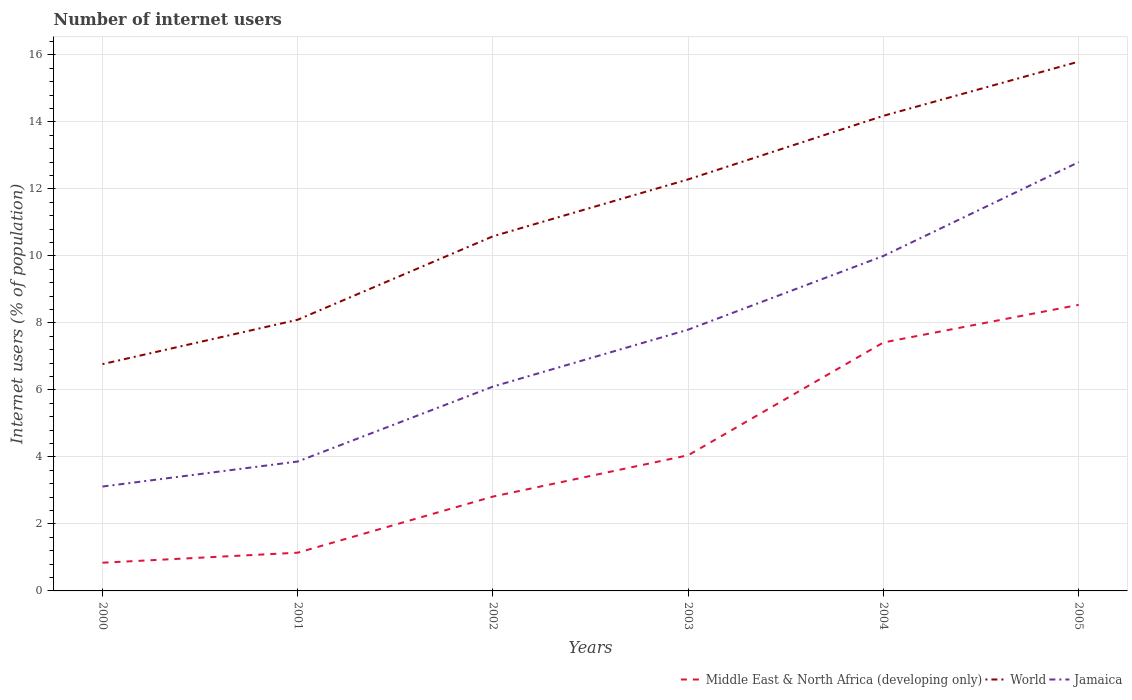How many different coloured lines are there?
Make the answer very short. 3. Does the line corresponding to Middle East & North Africa (developing only) intersect with the line corresponding to World?
Make the answer very short. No. Across all years, what is the maximum number of internet users in Middle East & North Africa (developing only)?
Ensure brevity in your answer.  0.84. In which year was the number of internet users in Jamaica maximum?
Ensure brevity in your answer.  2000. What is the total number of internet users in World in the graph?
Keep it short and to the point. -7.7. What is the difference between the highest and the second highest number of internet users in World?
Provide a succinct answer. 9.03. What is the difference between the highest and the lowest number of internet users in Middle East & North Africa (developing only)?
Give a very brief answer. 2. Is the number of internet users in World strictly greater than the number of internet users in Middle East & North Africa (developing only) over the years?
Provide a short and direct response. No. How many lines are there?
Give a very brief answer. 3. How many years are there in the graph?
Your response must be concise. 6. How many legend labels are there?
Give a very brief answer. 3. How are the legend labels stacked?
Give a very brief answer. Horizontal. What is the title of the graph?
Your answer should be very brief. Number of internet users. What is the label or title of the Y-axis?
Offer a very short reply. Internet users (% of population). What is the Internet users (% of population) of Middle East & North Africa (developing only) in 2000?
Offer a very short reply. 0.84. What is the Internet users (% of population) of World in 2000?
Make the answer very short. 6.77. What is the Internet users (% of population) in Jamaica in 2000?
Ensure brevity in your answer.  3.12. What is the Internet users (% of population) of Middle East & North Africa (developing only) in 2001?
Provide a succinct answer. 1.14. What is the Internet users (% of population) in World in 2001?
Ensure brevity in your answer.  8.1. What is the Internet users (% of population) in Jamaica in 2001?
Your response must be concise. 3.86. What is the Internet users (% of population) in Middle East & North Africa (developing only) in 2002?
Keep it short and to the point. 2.82. What is the Internet users (% of population) of World in 2002?
Provide a succinct answer. 10.59. What is the Internet users (% of population) of Jamaica in 2002?
Provide a succinct answer. 6.1. What is the Internet users (% of population) of Middle East & North Africa (developing only) in 2003?
Offer a very short reply. 4.05. What is the Internet users (% of population) of World in 2003?
Provide a short and direct response. 12.29. What is the Internet users (% of population) in Middle East & North Africa (developing only) in 2004?
Your response must be concise. 7.42. What is the Internet users (% of population) in World in 2004?
Your answer should be very brief. 14.18. What is the Internet users (% of population) in Jamaica in 2004?
Make the answer very short. 10. What is the Internet users (% of population) of Middle East & North Africa (developing only) in 2005?
Offer a very short reply. 8.54. What is the Internet users (% of population) in World in 2005?
Make the answer very short. 15.8. Across all years, what is the maximum Internet users (% of population) in Middle East & North Africa (developing only)?
Provide a short and direct response. 8.54. Across all years, what is the maximum Internet users (% of population) in World?
Provide a succinct answer. 15.8. Across all years, what is the maximum Internet users (% of population) in Jamaica?
Make the answer very short. 12.8. Across all years, what is the minimum Internet users (% of population) of Middle East & North Africa (developing only)?
Ensure brevity in your answer.  0.84. Across all years, what is the minimum Internet users (% of population) of World?
Provide a short and direct response. 6.77. Across all years, what is the minimum Internet users (% of population) of Jamaica?
Offer a very short reply. 3.12. What is the total Internet users (% of population) in Middle East & North Africa (developing only) in the graph?
Your response must be concise. 24.81. What is the total Internet users (% of population) of World in the graph?
Your answer should be compact. 67.72. What is the total Internet users (% of population) in Jamaica in the graph?
Make the answer very short. 43.68. What is the difference between the Internet users (% of population) in Middle East & North Africa (developing only) in 2000 and that in 2001?
Offer a terse response. -0.3. What is the difference between the Internet users (% of population) of World in 2000 and that in 2001?
Keep it short and to the point. -1.33. What is the difference between the Internet users (% of population) in Jamaica in 2000 and that in 2001?
Offer a terse response. -0.75. What is the difference between the Internet users (% of population) of Middle East & North Africa (developing only) in 2000 and that in 2002?
Offer a terse response. -1.97. What is the difference between the Internet users (% of population) of World in 2000 and that in 2002?
Offer a very short reply. -3.82. What is the difference between the Internet users (% of population) of Jamaica in 2000 and that in 2002?
Offer a very short reply. -2.98. What is the difference between the Internet users (% of population) of Middle East & North Africa (developing only) in 2000 and that in 2003?
Offer a very short reply. -3.21. What is the difference between the Internet users (% of population) in World in 2000 and that in 2003?
Offer a terse response. -5.51. What is the difference between the Internet users (% of population) of Jamaica in 2000 and that in 2003?
Keep it short and to the point. -4.68. What is the difference between the Internet users (% of population) of Middle East & North Africa (developing only) in 2000 and that in 2004?
Your answer should be compact. -6.57. What is the difference between the Internet users (% of population) in World in 2000 and that in 2004?
Give a very brief answer. -7.41. What is the difference between the Internet users (% of population) of Jamaica in 2000 and that in 2004?
Ensure brevity in your answer.  -6.88. What is the difference between the Internet users (% of population) of Middle East & North Africa (developing only) in 2000 and that in 2005?
Provide a succinct answer. -7.7. What is the difference between the Internet users (% of population) of World in 2000 and that in 2005?
Ensure brevity in your answer.  -9.03. What is the difference between the Internet users (% of population) in Jamaica in 2000 and that in 2005?
Your answer should be very brief. -9.68. What is the difference between the Internet users (% of population) in Middle East & North Africa (developing only) in 2001 and that in 2002?
Provide a short and direct response. -1.68. What is the difference between the Internet users (% of population) of World in 2001 and that in 2002?
Ensure brevity in your answer.  -2.49. What is the difference between the Internet users (% of population) in Jamaica in 2001 and that in 2002?
Keep it short and to the point. -2.24. What is the difference between the Internet users (% of population) in Middle East & North Africa (developing only) in 2001 and that in 2003?
Keep it short and to the point. -2.91. What is the difference between the Internet users (% of population) of World in 2001 and that in 2003?
Provide a short and direct response. -4.19. What is the difference between the Internet users (% of population) of Jamaica in 2001 and that in 2003?
Offer a very short reply. -3.94. What is the difference between the Internet users (% of population) in Middle East & North Africa (developing only) in 2001 and that in 2004?
Keep it short and to the point. -6.28. What is the difference between the Internet users (% of population) of World in 2001 and that in 2004?
Ensure brevity in your answer.  -6.09. What is the difference between the Internet users (% of population) of Jamaica in 2001 and that in 2004?
Your answer should be compact. -6.14. What is the difference between the Internet users (% of population) of Middle East & North Africa (developing only) in 2001 and that in 2005?
Offer a terse response. -7.4. What is the difference between the Internet users (% of population) of World in 2001 and that in 2005?
Your answer should be compact. -7.7. What is the difference between the Internet users (% of population) in Jamaica in 2001 and that in 2005?
Keep it short and to the point. -8.94. What is the difference between the Internet users (% of population) of Middle East & North Africa (developing only) in 2002 and that in 2003?
Give a very brief answer. -1.23. What is the difference between the Internet users (% of population) of World in 2002 and that in 2003?
Provide a succinct answer. -1.7. What is the difference between the Internet users (% of population) of Middle East & North Africa (developing only) in 2002 and that in 2004?
Ensure brevity in your answer.  -4.6. What is the difference between the Internet users (% of population) of World in 2002 and that in 2004?
Ensure brevity in your answer.  -3.6. What is the difference between the Internet users (% of population) in Jamaica in 2002 and that in 2004?
Your answer should be very brief. -3.9. What is the difference between the Internet users (% of population) of Middle East & North Africa (developing only) in 2002 and that in 2005?
Make the answer very short. -5.72. What is the difference between the Internet users (% of population) of World in 2002 and that in 2005?
Offer a terse response. -5.21. What is the difference between the Internet users (% of population) in Middle East & North Africa (developing only) in 2003 and that in 2004?
Offer a very short reply. -3.37. What is the difference between the Internet users (% of population) of World in 2003 and that in 2004?
Offer a terse response. -1.9. What is the difference between the Internet users (% of population) of Middle East & North Africa (developing only) in 2003 and that in 2005?
Make the answer very short. -4.49. What is the difference between the Internet users (% of population) in World in 2003 and that in 2005?
Ensure brevity in your answer.  -3.51. What is the difference between the Internet users (% of population) of Jamaica in 2003 and that in 2005?
Provide a succinct answer. -5. What is the difference between the Internet users (% of population) of Middle East & North Africa (developing only) in 2004 and that in 2005?
Offer a terse response. -1.12. What is the difference between the Internet users (% of population) of World in 2004 and that in 2005?
Offer a very short reply. -1.62. What is the difference between the Internet users (% of population) in Jamaica in 2004 and that in 2005?
Your answer should be very brief. -2.8. What is the difference between the Internet users (% of population) of Middle East & North Africa (developing only) in 2000 and the Internet users (% of population) of World in 2001?
Your response must be concise. -7.25. What is the difference between the Internet users (% of population) in Middle East & North Africa (developing only) in 2000 and the Internet users (% of population) in Jamaica in 2001?
Ensure brevity in your answer.  -3.02. What is the difference between the Internet users (% of population) in World in 2000 and the Internet users (% of population) in Jamaica in 2001?
Make the answer very short. 2.91. What is the difference between the Internet users (% of population) of Middle East & North Africa (developing only) in 2000 and the Internet users (% of population) of World in 2002?
Provide a short and direct response. -9.74. What is the difference between the Internet users (% of population) in Middle East & North Africa (developing only) in 2000 and the Internet users (% of population) in Jamaica in 2002?
Provide a short and direct response. -5.26. What is the difference between the Internet users (% of population) in World in 2000 and the Internet users (% of population) in Jamaica in 2002?
Your answer should be very brief. 0.67. What is the difference between the Internet users (% of population) of Middle East & North Africa (developing only) in 2000 and the Internet users (% of population) of World in 2003?
Keep it short and to the point. -11.44. What is the difference between the Internet users (% of population) in Middle East & North Africa (developing only) in 2000 and the Internet users (% of population) in Jamaica in 2003?
Give a very brief answer. -6.96. What is the difference between the Internet users (% of population) in World in 2000 and the Internet users (% of population) in Jamaica in 2003?
Provide a succinct answer. -1.03. What is the difference between the Internet users (% of population) in Middle East & North Africa (developing only) in 2000 and the Internet users (% of population) in World in 2004?
Your answer should be compact. -13.34. What is the difference between the Internet users (% of population) in Middle East & North Africa (developing only) in 2000 and the Internet users (% of population) in Jamaica in 2004?
Provide a succinct answer. -9.16. What is the difference between the Internet users (% of population) in World in 2000 and the Internet users (% of population) in Jamaica in 2004?
Your response must be concise. -3.23. What is the difference between the Internet users (% of population) of Middle East & North Africa (developing only) in 2000 and the Internet users (% of population) of World in 2005?
Give a very brief answer. -14.96. What is the difference between the Internet users (% of population) of Middle East & North Africa (developing only) in 2000 and the Internet users (% of population) of Jamaica in 2005?
Make the answer very short. -11.96. What is the difference between the Internet users (% of population) of World in 2000 and the Internet users (% of population) of Jamaica in 2005?
Your answer should be compact. -6.03. What is the difference between the Internet users (% of population) of Middle East & North Africa (developing only) in 2001 and the Internet users (% of population) of World in 2002?
Ensure brevity in your answer.  -9.45. What is the difference between the Internet users (% of population) in Middle East & North Africa (developing only) in 2001 and the Internet users (% of population) in Jamaica in 2002?
Your answer should be very brief. -4.96. What is the difference between the Internet users (% of population) of World in 2001 and the Internet users (% of population) of Jamaica in 2002?
Offer a very short reply. 2. What is the difference between the Internet users (% of population) in Middle East & North Africa (developing only) in 2001 and the Internet users (% of population) in World in 2003?
Provide a succinct answer. -11.14. What is the difference between the Internet users (% of population) in Middle East & North Africa (developing only) in 2001 and the Internet users (% of population) in Jamaica in 2003?
Ensure brevity in your answer.  -6.66. What is the difference between the Internet users (% of population) of World in 2001 and the Internet users (% of population) of Jamaica in 2003?
Give a very brief answer. 0.3. What is the difference between the Internet users (% of population) of Middle East & North Africa (developing only) in 2001 and the Internet users (% of population) of World in 2004?
Your response must be concise. -13.04. What is the difference between the Internet users (% of population) in Middle East & North Africa (developing only) in 2001 and the Internet users (% of population) in Jamaica in 2004?
Give a very brief answer. -8.86. What is the difference between the Internet users (% of population) of World in 2001 and the Internet users (% of population) of Jamaica in 2004?
Offer a very short reply. -1.9. What is the difference between the Internet users (% of population) of Middle East & North Africa (developing only) in 2001 and the Internet users (% of population) of World in 2005?
Your answer should be very brief. -14.66. What is the difference between the Internet users (% of population) of Middle East & North Africa (developing only) in 2001 and the Internet users (% of population) of Jamaica in 2005?
Give a very brief answer. -11.66. What is the difference between the Internet users (% of population) in World in 2001 and the Internet users (% of population) in Jamaica in 2005?
Offer a very short reply. -4.7. What is the difference between the Internet users (% of population) in Middle East & North Africa (developing only) in 2002 and the Internet users (% of population) in World in 2003?
Your answer should be compact. -9.47. What is the difference between the Internet users (% of population) in Middle East & North Africa (developing only) in 2002 and the Internet users (% of population) in Jamaica in 2003?
Offer a very short reply. -4.98. What is the difference between the Internet users (% of population) of World in 2002 and the Internet users (% of population) of Jamaica in 2003?
Provide a short and direct response. 2.79. What is the difference between the Internet users (% of population) in Middle East & North Africa (developing only) in 2002 and the Internet users (% of population) in World in 2004?
Keep it short and to the point. -11.37. What is the difference between the Internet users (% of population) of Middle East & North Africa (developing only) in 2002 and the Internet users (% of population) of Jamaica in 2004?
Offer a terse response. -7.18. What is the difference between the Internet users (% of population) in World in 2002 and the Internet users (% of population) in Jamaica in 2004?
Make the answer very short. 0.59. What is the difference between the Internet users (% of population) of Middle East & North Africa (developing only) in 2002 and the Internet users (% of population) of World in 2005?
Your answer should be compact. -12.98. What is the difference between the Internet users (% of population) in Middle East & North Africa (developing only) in 2002 and the Internet users (% of population) in Jamaica in 2005?
Offer a terse response. -9.98. What is the difference between the Internet users (% of population) in World in 2002 and the Internet users (% of population) in Jamaica in 2005?
Keep it short and to the point. -2.21. What is the difference between the Internet users (% of population) of Middle East & North Africa (developing only) in 2003 and the Internet users (% of population) of World in 2004?
Offer a terse response. -10.13. What is the difference between the Internet users (% of population) of Middle East & North Africa (developing only) in 2003 and the Internet users (% of population) of Jamaica in 2004?
Keep it short and to the point. -5.95. What is the difference between the Internet users (% of population) of World in 2003 and the Internet users (% of population) of Jamaica in 2004?
Ensure brevity in your answer.  2.29. What is the difference between the Internet users (% of population) of Middle East & North Africa (developing only) in 2003 and the Internet users (% of population) of World in 2005?
Offer a very short reply. -11.75. What is the difference between the Internet users (% of population) of Middle East & North Africa (developing only) in 2003 and the Internet users (% of population) of Jamaica in 2005?
Give a very brief answer. -8.75. What is the difference between the Internet users (% of population) in World in 2003 and the Internet users (% of population) in Jamaica in 2005?
Provide a short and direct response. -0.51. What is the difference between the Internet users (% of population) of Middle East & North Africa (developing only) in 2004 and the Internet users (% of population) of World in 2005?
Offer a very short reply. -8.38. What is the difference between the Internet users (% of population) in Middle East & North Africa (developing only) in 2004 and the Internet users (% of population) in Jamaica in 2005?
Give a very brief answer. -5.38. What is the difference between the Internet users (% of population) in World in 2004 and the Internet users (% of population) in Jamaica in 2005?
Provide a succinct answer. 1.38. What is the average Internet users (% of population) in Middle East & North Africa (developing only) per year?
Offer a very short reply. 4.13. What is the average Internet users (% of population) in World per year?
Your response must be concise. 11.29. What is the average Internet users (% of population) of Jamaica per year?
Your answer should be compact. 7.28. In the year 2000, what is the difference between the Internet users (% of population) in Middle East & North Africa (developing only) and Internet users (% of population) in World?
Make the answer very short. -5.93. In the year 2000, what is the difference between the Internet users (% of population) in Middle East & North Africa (developing only) and Internet users (% of population) in Jamaica?
Offer a terse response. -2.27. In the year 2000, what is the difference between the Internet users (% of population) of World and Internet users (% of population) of Jamaica?
Your response must be concise. 3.65. In the year 2001, what is the difference between the Internet users (% of population) in Middle East & North Africa (developing only) and Internet users (% of population) in World?
Offer a terse response. -6.95. In the year 2001, what is the difference between the Internet users (% of population) in Middle East & North Africa (developing only) and Internet users (% of population) in Jamaica?
Keep it short and to the point. -2.72. In the year 2001, what is the difference between the Internet users (% of population) of World and Internet users (% of population) of Jamaica?
Keep it short and to the point. 4.23. In the year 2002, what is the difference between the Internet users (% of population) in Middle East & North Africa (developing only) and Internet users (% of population) in World?
Your answer should be very brief. -7.77. In the year 2002, what is the difference between the Internet users (% of population) of Middle East & North Africa (developing only) and Internet users (% of population) of Jamaica?
Ensure brevity in your answer.  -3.28. In the year 2002, what is the difference between the Internet users (% of population) of World and Internet users (% of population) of Jamaica?
Provide a succinct answer. 4.49. In the year 2003, what is the difference between the Internet users (% of population) of Middle East & North Africa (developing only) and Internet users (% of population) of World?
Provide a short and direct response. -8.24. In the year 2003, what is the difference between the Internet users (% of population) in Middle East & North Africa (developing only) and Internet users (% of population) in Jamaica?
Provide a succinct answer. -3.75. In the year 2003, what is the difference between the Internet users (% of population) of World and Internet users (% of population) of Jamaica?
Provide a succinct answer. 4.49. In the year 2004, what is the difference between the Internet users (% of population) in Middle East & North Africa (developing only) and Internet users (% of population) in World?
Provide a short and direct response. -6.77. In the year 2004, what is the difference between the Internet users (% of population) of Middle East & North Africa (developing only) and Internet users (% of population) of Jamaica?
Your answer should be compact. -2.58. In the year 2004, what is the difference between the Internet users (% of population) in World and Internet users (% of population) in Jamaica?
Your answer should be compact. 4.18. In the year 2005, what is the difference between the Internet users (% of population) of Middle East & North Africa (developing only) and Internet users (% of population) of World?
Keep it short and to the point. -7.26. In the year 2005, what is the difference between the Internet users (% of population) of Middle East & North Africa (developing only) and Internet users (% of population) of Jamaica?
Ensure brevity in your answer.  -4.26. What is the ratio of the Internet users (% of population) of Middle East & North Africa (developing only) in 2000 to that in 2001?
Your answer should be very brief. 0.74. What is the ratio of the Internet users (% of population) in World in 2000 to that in 2001?
Your answer should be compact. 0.84. What is the ratio of the Internet users (% of population) in Jamaica in 2000 to that in 2001?
Your response must be concise. 0.81. What is the ratio of the Internet users (% of population) of Middle East & North Africa (developing only) in 2000 to that in 2002?
Give a very brief answer. 0.3. What is the ratio of the Internet users (% of population) of World in 2000 to that in 2002?
Your response must be concise. 0.64. What is the ratio of the Internet users (% of population) of Jamaica in 2000 to that in 2002?
Offer a terse response. 0.51. What is the ratio of the Internet users (% of population) of Middle East & North Africa (developing only) in 2000 to that in 2003?
Offer a terse response. 0.21. What is the ratio of the Internet users (% of population) of World in 2000 to that in 2003?
Your answer should be compact. 0.55. What is the ratio of the Internet users (% of population) of Jamaica in 2000 to that in 2003?
Your answer should be very brief. 0.4. What is the ratio of the Internet users (% of population) of Middle East & North Africa (developing only) in 2000 to that in 2004?
Offer a terse response. 0.11. What is the ratio of the Internet users (% of population) of World in 2000 to that in 2004?
Make the answer very short. 0.48. What is the ratio of the Internet users (% of population) of Jamaica in 2000 to that in 2004?
Offer a very short reply. 0.31. What is the ratio of the Internet users (% of population) of Middle East & North Africa (developing only) in 2000 to that in 2005?
Your answer should be very brief. 0.1. What is the ratio of the Internet users (% of population) in World in 2000 to that in 2005?
Ensure brevity in your answer.  0.43. What is the ratio of the Internet users (% of population) in Jamaica in 2000 to that in 2005?
Ensure brevity in your answer.  0.24. What is the ratio of the Internet users (% of population) in Middle East & North Africa (developing only) in 2001 to that in 2002?
Your response must be concise. 0.41. What is the ratio of the Internet users (% of population) in World in 2001 to that in 2002?
Give a very brief answer. 0.76. What is the ratio of the Internet users (% of population) of Jamaica in 2001 to that in 2002?
Your answer should be very brief. 0.63. What is the ratio of the Internet users (% of population) of Middle East & North Africa (developing only) in 2001 to that in 2003?
Your answer should be compact. 0.28. What is the ratio of the Internet users (% of population) in World in 2001 to that in 2003?
Provide a short and direct response. 0.66. What is the ratio of the Internet users (% of population) of Jamaica in 2001 to that in 2003?
Make the answer very short. 0.5. What is the ratio of the Internet users (% of population) of Middle East & North Africa (developing only) in 2001 to that in 2004?
Offer a very short reply. 0.15. What is the ratio of the Internet users (% of population) of World in 2001 to that in 2004?
Give a very brief answer. 0.57. What is the ratio of the Internet users (% of population) in Jamaica in 2001 to that in 2004?
Keep it short and to the point. 0.39. What is the ratio of the Internet users (% of population) of Middle East & North Africa (developing only) in 2001 to that in 2005?
Offer a terse response. 0.13. What is the ratio of the Internet users (% of population) in World in 2001 to that in 2005?
Keep it short and to the point. 0.51. What is the ratio of the Internet users (% of population) in Jamaica in 2001 to that in 2005?
Ensure brevity in your answer.  0.3. What is the ratio of the Internet users (% of population) of Middle East & North Africa (developing only) in 2002 to that in 2003?
Offer a terse response. 0.7. What is the ratio of the Internet users (% of population) in World in 2002 to that in 2003?
Your answer should be compact. 0.86. What is the ratio of the Internet users (% of population) of Jamaica in 2002 to that in 2003?
Offer a very short reply. 0.78. What is the ratio of the Internet users (% of population) in Middle East & North Africa (developing only) in 2002 to that in 2004?
Your answer should be very brief. 0.38. What is the ratio of the Internet users (% of population) in World in 2002 to that in 2004?
Your answer should be very brief. 0.75. What is the ratio of the Internet users (% of population) in Jamaica in 2002 to that in 2004?
Your answer should be compact. 0.61. What is the ratio of the Internet users (% of population) of Middle East & North Africa (developing only) in 2002 to that in 2005?
Make the answer very short. 0.33. What is the ratio of the Internet users (% of population) in World in 2002 to that in 2005?
Offer a very short reply. 0.67. What is the ratio of the Internet users (% of population) in Jamaica in 2002 to that in 2005?
Keep it short and to the point. 0.48. What is the ratio of the Internet users (% of population) in Middle East & North Africa (developing only) in 2003 to that in 2004?
Your answer should be compact. 0.55. What is the ratio of the Internet users (% of population) of World in 2003 to that in 2004?
Make the answer very short. 0.87. What is the ratio of the Internet users (% of population) in Jamaica in 2003 to that in 2004?
Offer a terse response. 0.78. What is the ratio of the Internet users (% of population) in Middle East & North Africa (developing only) in 2003 to that in 2005?
Offer a terse response. 0.47. What is the ratio of the Internet users (% of population) of World in 2003 to that in 2005?
Give a very brief answer. 0.78. What is the ratio of the Internet users (% of population) in Jamaica in 2003 to that in 2005?
Provide a short and direct response. 0.61. What is the ratio of the Internet users (% of population) in Middle East & North Africa (developing only) in 2004 to that in 2005?
Keep it short and to the point. 0.87. What is the ratio of the Internet users (% of population) in World in 2004 to that in 2005?
Offer a very short reply. 0.9. What is the ratio of the Internet users (% of population) in Jamaica in 2004 to that in 2005?
Your response must be concise. 0.78. What is the difference between the highest and the second highest Internet users (% of population) of Middle East & North Africa (developing only)?
Provide a succinct answer. 1.12. What is the difference between the highest and the second highest Internet users (% of population) of World?
Your response must be concise. 1.62. What is the difference between the highest and the second highest Internet users (% of population) in Jamaica?
Provide a short and direct response. 2.8. What is the difference between the highest and the lowest Internet users (% of population) in Middle East & North Africa (developing only)?
Ensure brevity in your answer.  7.7. What is the difference between the highest and the lowest Internet users (% of population) of World?
Provide a succinct answer. 9.03. What is the difference between the highest and the lowest Internet users (% of population) in Jamaica?
Offer a terse response. 9.68. 